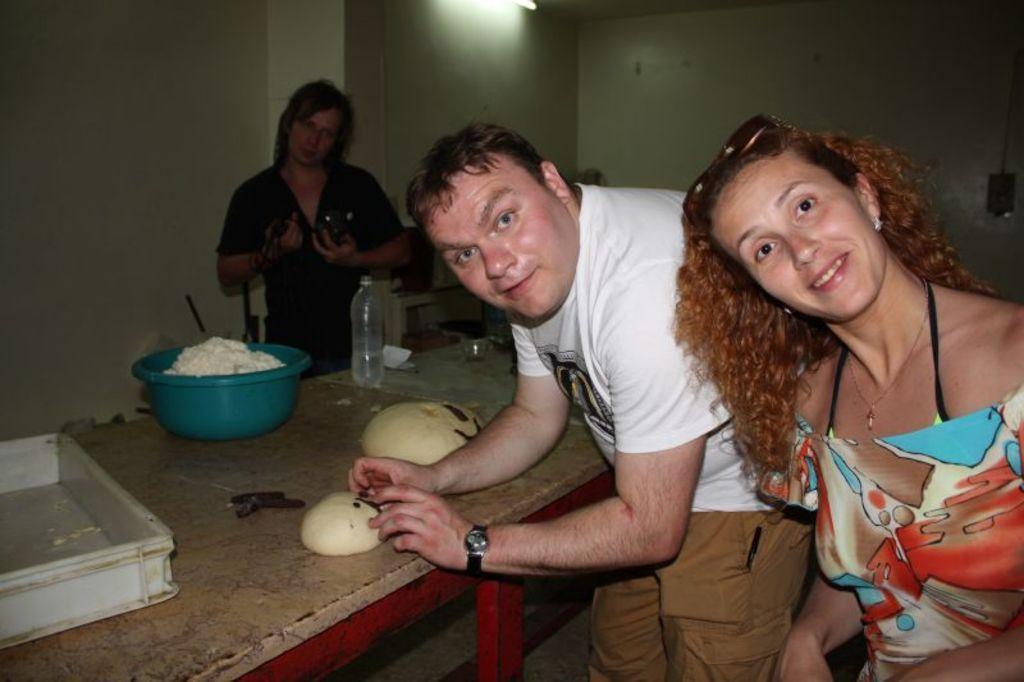In one or two sentences, can you explain what this image depicts? In the center of the image we can see a table and there are tubs, dough, bottles and glasses placed on the table. On the right there are two people standing. In the background we can see another person and there is a wall. At the top there is light. 